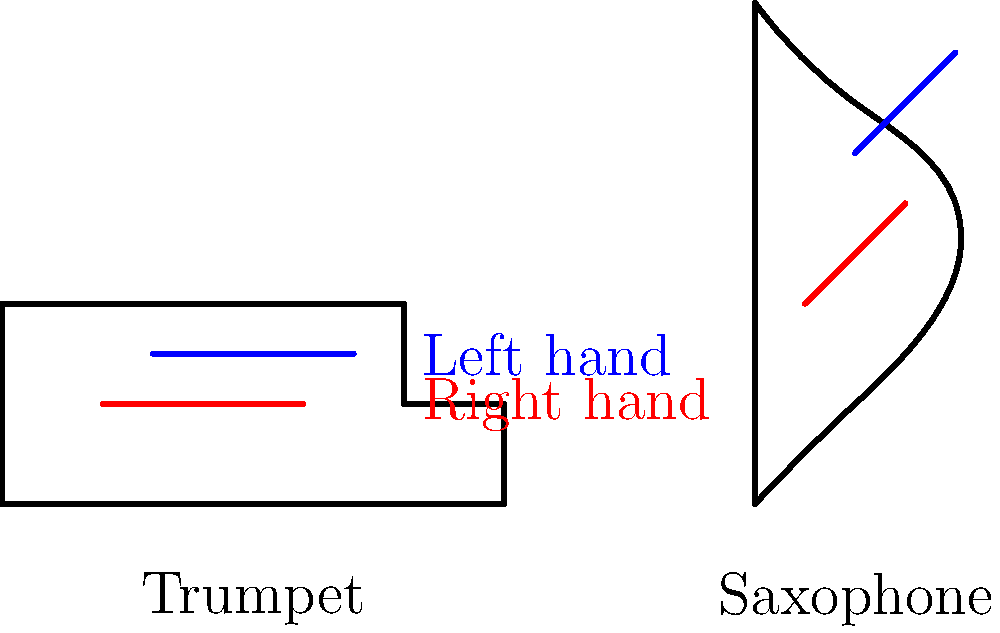Based on the simple outlines of a trumpet and saxophone shown above, what is the primary difference in hand positioning between these two instruments? To understand the difference in hand positioning between trumpet and saxophone, let's analyze the diagram step-by-step:

1. Trumpet hand position:
   - The right hand (red line) is positioned near the valves, in the middle of the instrument.
   - The left hand (blue line) is placed slightly above the right hand, supporting the instrument.
   - Both hands are relatively close together and in front of the player's body.

2. Saxophone hand position:
   - The right hand (red line) is positioned lower on the instrument, likely near the keys for the lower register.
   - The left hand (blue line) is placed higher up on the instrument, near the upper keys and closer to the mouthpiece.
   - The hands are more spread apart compared to the trumpet positioning.

3. Key differences:
   - Hand spread: On the saxophone, the hands are more widely separated vertically along the instrument's body. On the trumpet, the hands are closer together.
   - Orientation: The saxophone requires a more vertical hand orientation, while the trumpet uses a more horizontal hand position.
   - Function: On the saxophone, both hands are actively involved in pressing keys. On the trumpet, the right hand operates the valves while the left hand primarily supports the instrument.

The primary difference is the vertical spread of hand positions on the saxophone compared to the closer, more horizontally aligned hand positions on the trumpet.
Answer: Wider vertical hand spread on saxophone versus closer horizontal positioning on trumpet. 